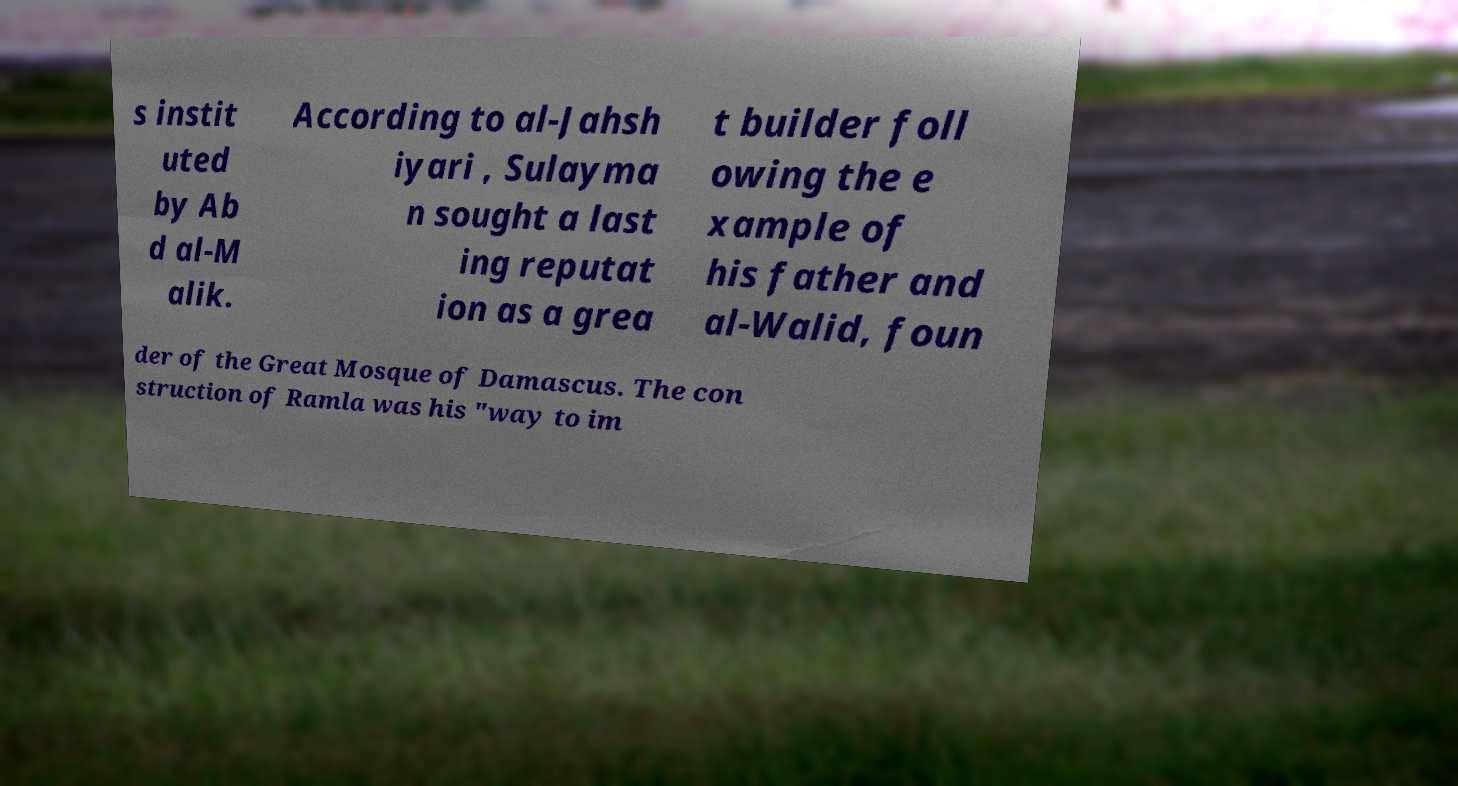For documentation purposes, I need the text within this image transcribed. Could you provide that? s instit uted by Ab d al-M alik. According to al-Jahsh iyari , Sulayma n sought a last ing reputat ion as a grea t builder foll owing the e xample of his father and al-Walid, foun der of the Great Mosque of Damascus. The con struction of Ramla was his "way to im 